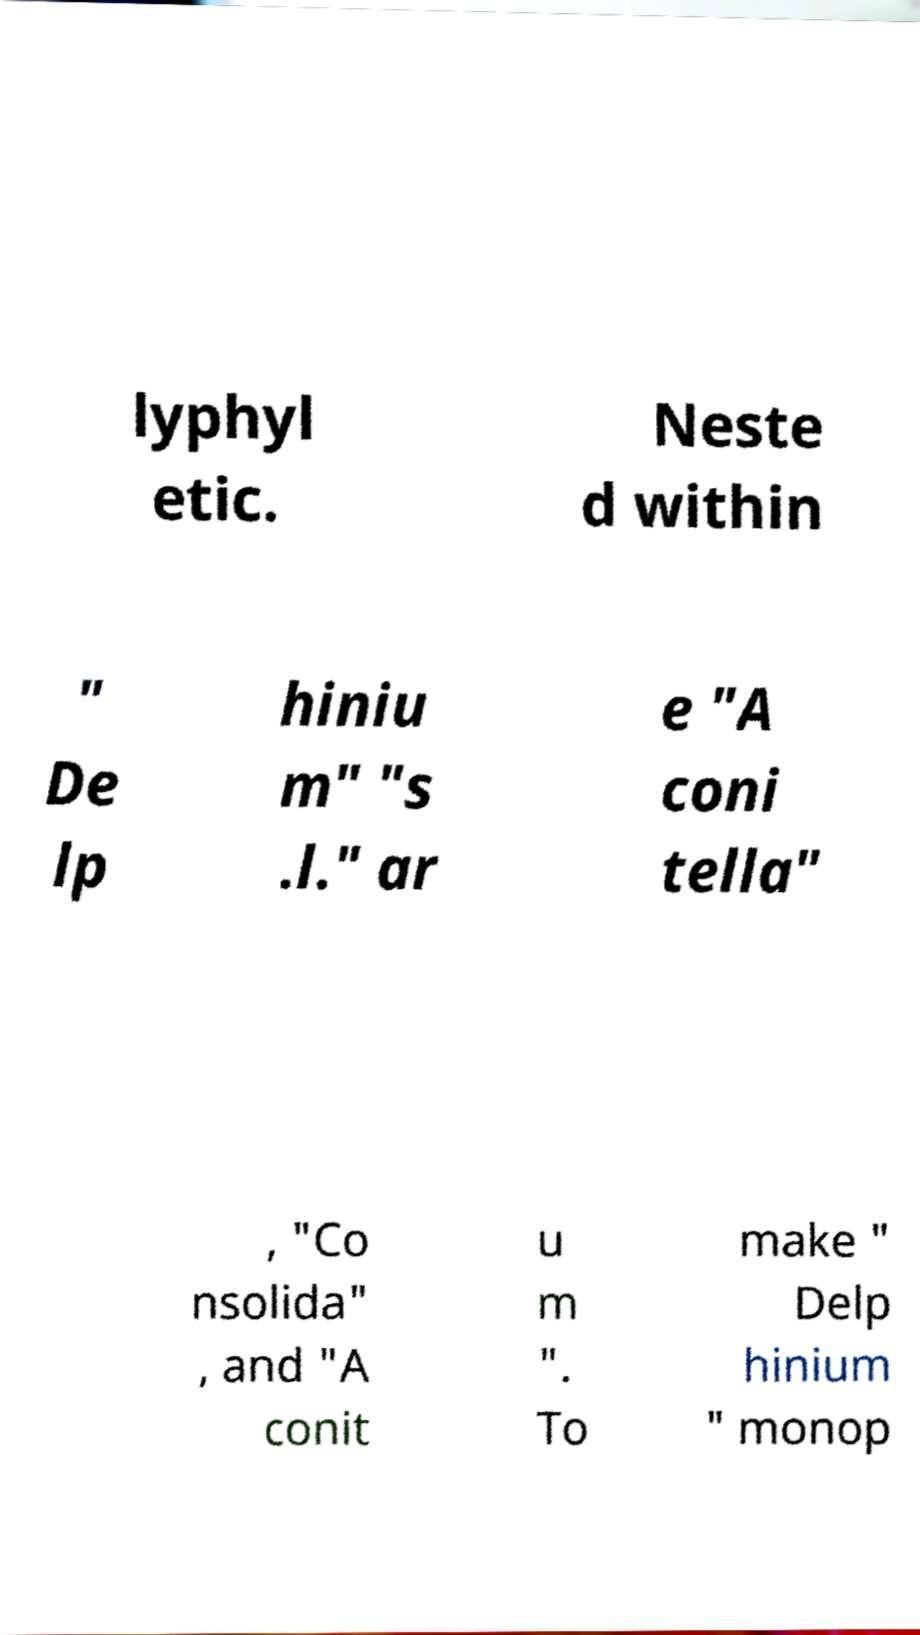Please identify and transcribe the text found in this image. lyphyl etic. Neste d within " De lp hiniu m" "s .l." ar e "A coni tella" , "Co nsolida" , and "A conit u m ". To make " Delp hinium " monop 